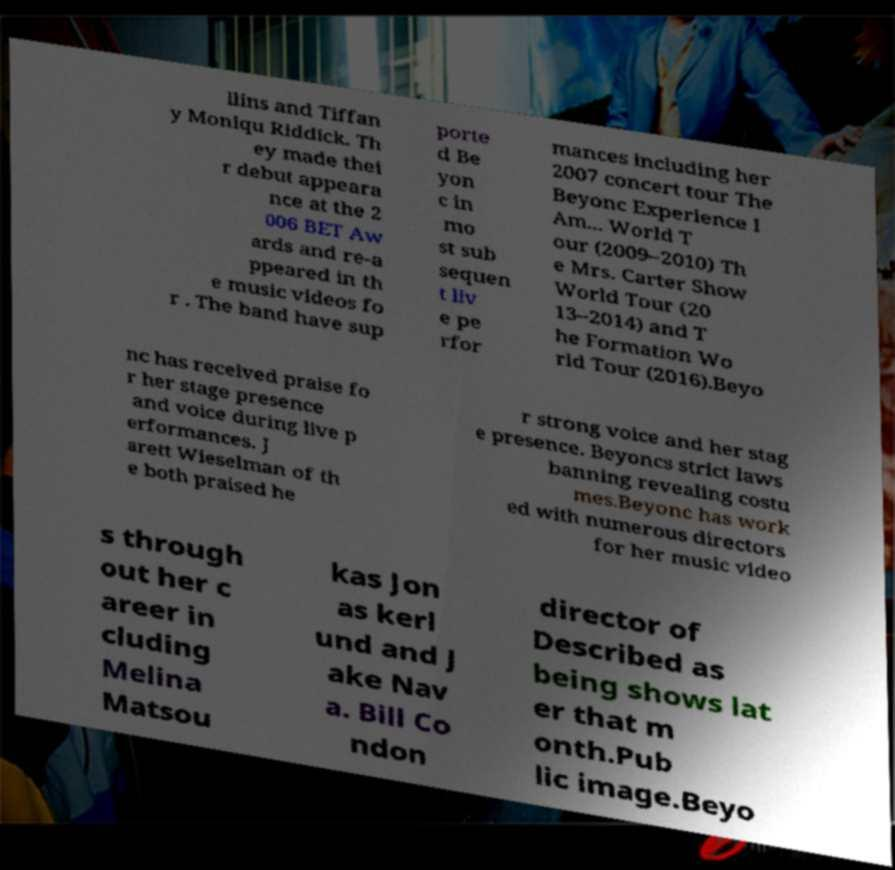Could you extract and type out the text from this image? llins and Tiffan y Moniqu Riddick. Th ey made thei r debut appeara nce at the 2 006 BET Aw ards and re-a ppeared in th e music videos fo r . The band have sup porte d Be yon c in mo st sub sequen t liv e pe rfor mances including her 2007 concert tour The Beyonc Experience I Am... World T our (2009–2010) Th e Mrs. Carter Show World Tour (20 13–2014) and T he Formation Wo rld Tour (2016).Beyo nc has received praise fo r her stage presence and voice during live p erformances. J arett Wieselman of th e both praised he r strong voice and her stag e presence. Beyoncs strict laws banning revealing costu mes.Beyonc has work ed with numerous directors for her music video s through out her c areer in cluding Melina Matsou kas Jon as kerl und and J ake Nav a. Bill Co ndon director of Described as being shows lat er that m onth.Pub lic image.Beyo 